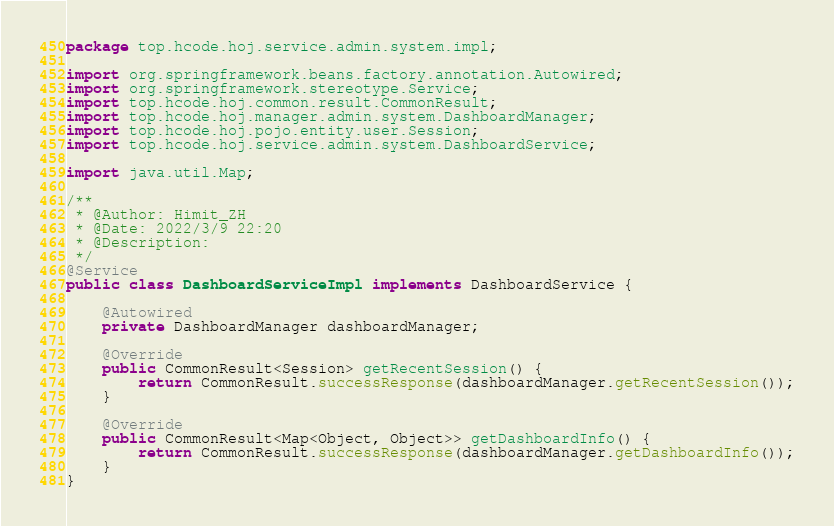Convert code to text. <code><loc_0><loc_0><loc_500><loc_500><_Java_>package top.hcode.hoj.service.admin.system.impl;

import org.springframework.beans.factory.annotation.Autowired;
import org.springframework.stereotype.Service;
import top.hcode.hoj.common.result.CommonResult;
import top.hcode.hoj.manager.admin.system.DashboardManager;
import top.hcode.hoj.pojo.entity.user.Session;
import top.hcode.hoj.service.admin.system.DashboardService;

import java.util.Map;

/**
 * @Author: Himit_ZH
 * @Date: 2022/3/9 22:20
 * @Description:
 */
@Service
public class DashboardServiceImpl implements DashboardService {

    @Autowired
    private DashboardManager dashboardManager;

    @Override
    public CommonResult<Session> getRecentSession() {
        return CommonResult.successResponse(dashboardManager.getRecentSession());
    }

    @Override
    public CommonResult<Map<Object, Object>> getDashboardInfo() {
        return CommonResult.successResponse(dashboardManager.getDashboardInfo());
    }
}</code> 